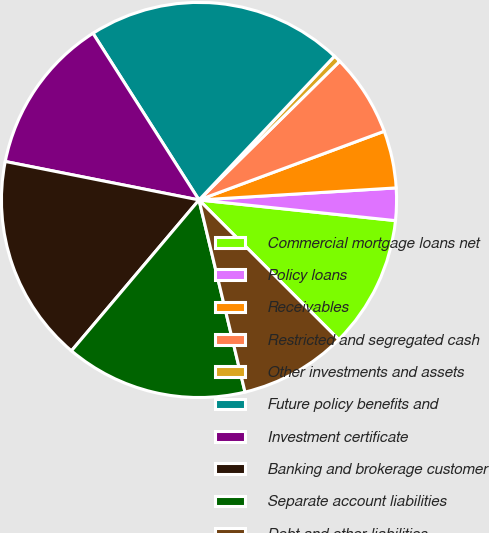Convert chart to OTSL. <chart><loc_0><loc_0><loc_500><loc_500><pie_chart><fcel>Commercial mortgage loans net<fcel>Policy loans<fcel>Receivables<fcel>Restricted and segregated cash<fcel>Other investments and assets<fcel>Future policy benefits and<fcel>Investment certificate<fcel>Banking and brokerage customer<fcel>Separate account liabilities<fcel>Debt and other liabilities<nl><fcel>10.82%<fcel>2.64%<fcel>4.68%<fcel>6.73%<fcel>0.59%<fcel>21.04%<fcel>12.86%<fcel>16.95%<fcel>14.91%<fcel>8.77%<nl></chart> 